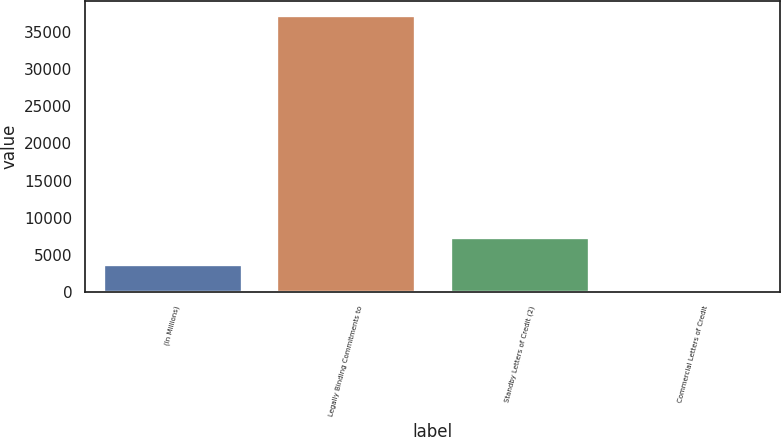Convert chart. <chart><loc_0><loc_0><loc_500><loc_500><bar_chart><fcel>(In Millions)<fcel>Legally Binding Commitments to<fcel>Standby Letters of Credit (2)<fcel>Commercial Letters of Credit<nl><fcel>3740.18<fcel>37247<fcel>7463.16<fcel>17.2<nl></chart> 